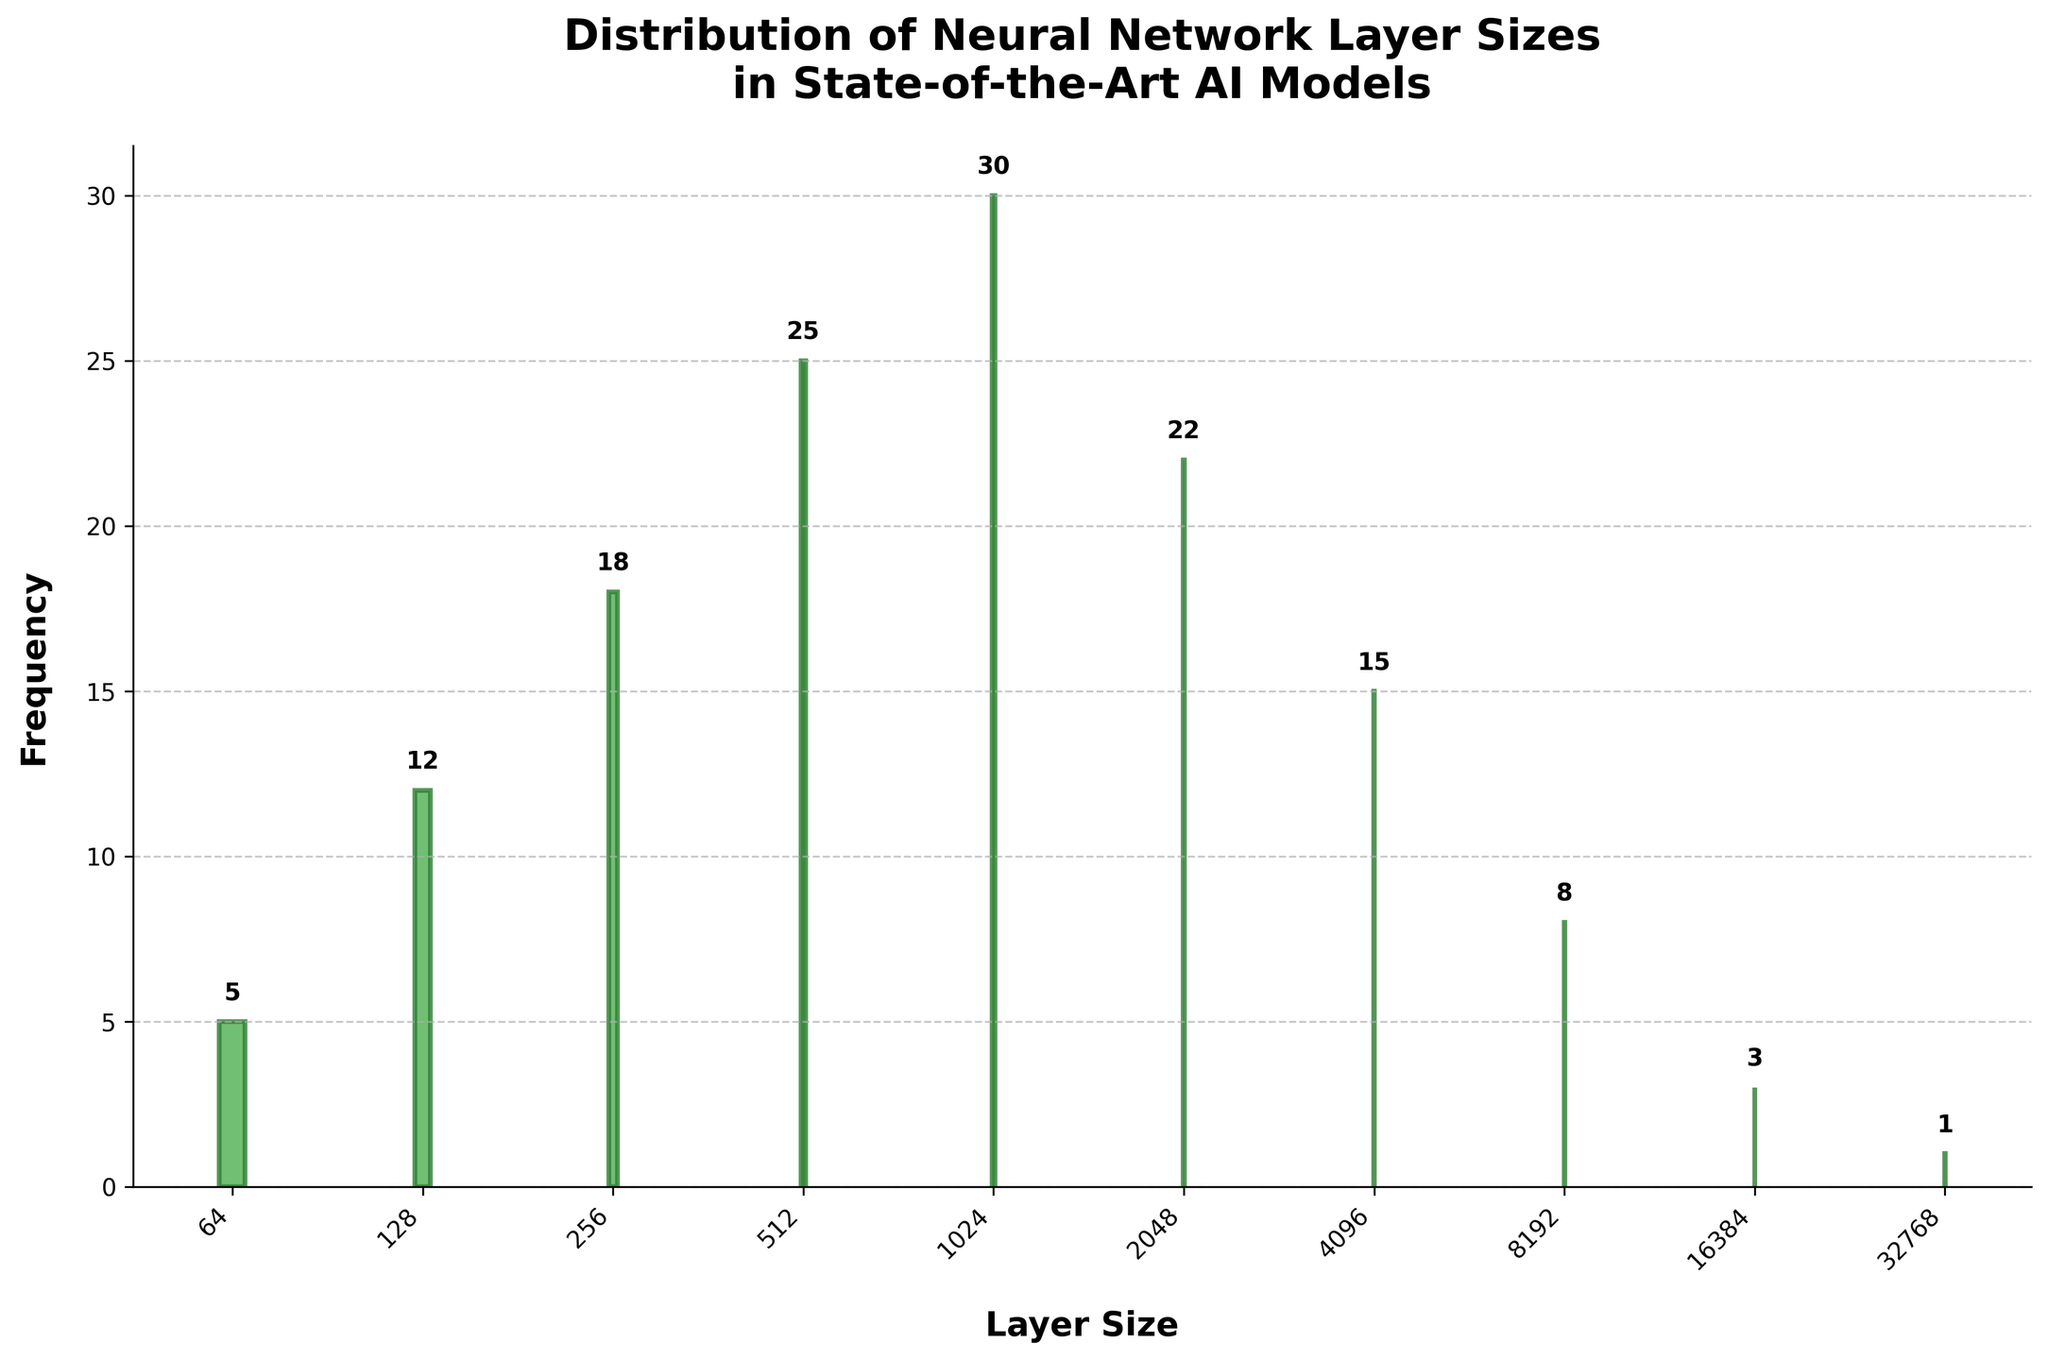What is the title of the figure? The figure's title is presented at the top and usually provides a brief summary of the visual data representation. In this case, it says "Distribution of Neural Network Layer Sizes in State-of-the-Art AI Models."
Answer: Distribution of Neural Network Layer Sizes in State-of-the-Art AI Models Which layer size has the highest frequency, and what is it? The highest bar in the histogram represents the most frequent layer size. This is the bar closest to the y-axis maximum. Here, the value of this bar is 30, and its corresponding layer size is 1024.
Answer: 1024, 30 How many layer sizes have a frequency of at least 20? To determine this, we need to count the bars that reach or exceed the frequency value of 20. The relevant layer sizes are those for 512, 1024, and 2048, each with frequencies of 25, 30, and 22, respectively.
Answer: 3 What is the combined frequency of layer sizes lower than 512? Add the frequencies of the layer sizes 64 (5), 128 (12), and 256 (18). The sum is 5 + 12 + 18 = 35.
Answer: 35 Are there more AI models with layer sizes greater than 4096 or less than 4096? To find this, we compare the combined frequencies for layer sizes less and more than 4096. For less than 4096: 5+12+18+25+30+22 (512) = 112. For greater than 4096: 15+8+3+1 = 27.
Answer: Less than 4096 Which is the least common layer size and what is its frequency? The smallest bar represents the least frequent layer size. This is the bar with the value 1, corresponding to the layer size 32768.
Answer: 32768, 1 What is the difference in frequency between the most common and least common layer sizes? The most common layer size has a frequency of 30, while the least common has a frequency of 1. The difference is 30 - 1 = 29.
Answer: 29 What's the average frequency of AI models with layer sizes between 512 and 2048 inclusive? For layer sizes 512, 1024, and 2048, add the frequencies (25 + 30 + 22) and divide by 3. The total sum is 77, and the average is 77/3 ≈ 25.67.
Answer: 25.67 Is there a notable pattern in the distribution of neural network layer sizes? Observing the histogram, we see an initial rise and peak at mid-size layers (1024), followed by a gradual decline. This indicates that moderate layer sizes are most common in state-of-the-art AI models.
Answer: Moderate layer sizes are most common 